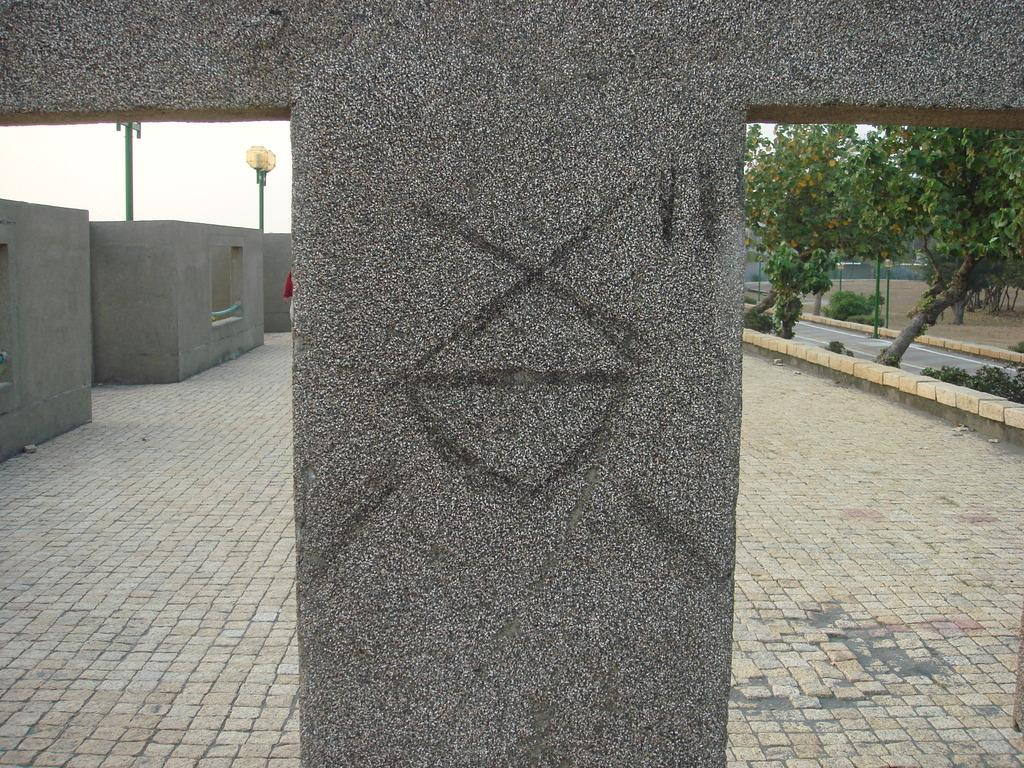What is the main subject in the middle of the image? There is a stone in the middle of the image. What can be seen on the left side of the image? There are walls and a light on the left side of the image. What type of vegetation is on the right side of the image? There are trees on the right side of the image. What else is present on the right side of the image? There is a road on the right side of the image. Can you tell me how many berries are growing on the stone in the image? There are no berries present in the image; it features a stone, walls, a light, trees, and a road. Is there a milk carton visible in the image? There is no milk carton present in the image. 